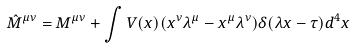Convert formula to latex. <formula><loc_0><loc_0><loc_500><loc_500>{ \hat { M } } ^ { \mu \nu } = M ^ { \mu \nu } + \int \nolimits V ( x ) ( x ^ { \nu } \lambda ^ { \mu } - x ^ { \mu } \lambda ^ { \nu } ) \delta ( \lambda x - \tau ) d ^ { 4 } x</formula> 